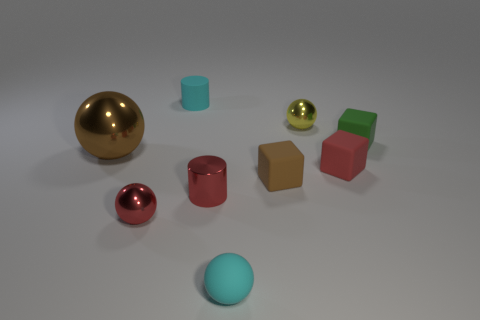Are there any other things that have the same size as the brown sphere?
Provide a short and direct response. No. Is the number of green blocks that are on the right side of the rubber sphere the same as the number of green rubber objects?
Keep it short and to the point. Yes. The brown object that is made of the same material as the cyan cylinder is what shape?
Ensure brevity in your answer.  Cube. Is there a small rubber cube of the same color as the small rubber cylinder?
Provide a succinct answer. No. What number of metal objects are big gray cylinders or cubes?
Provide a short and direct response. 0. What number of balls are behind the brown object that is in front of the big brown sphere?
Offer a very short reply. 2. What number of tiny cyan things have the same material as the large brown thing?
Give a very brief answer. 0. What number of big objects are either yellow matte cubes or red cylinders?
Keep it short and to the point. 0. What shape is the tiny thing that is both in front of the rubber cylinder and behind the green matte cube?
Provide a short and direct response. Sphere. Is the material of the large object the same as the cyan ball?
Give a very brief answer. No. 